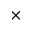<formula> <loc_0><loc_0><loc_500><loc_500>\times</formula> 